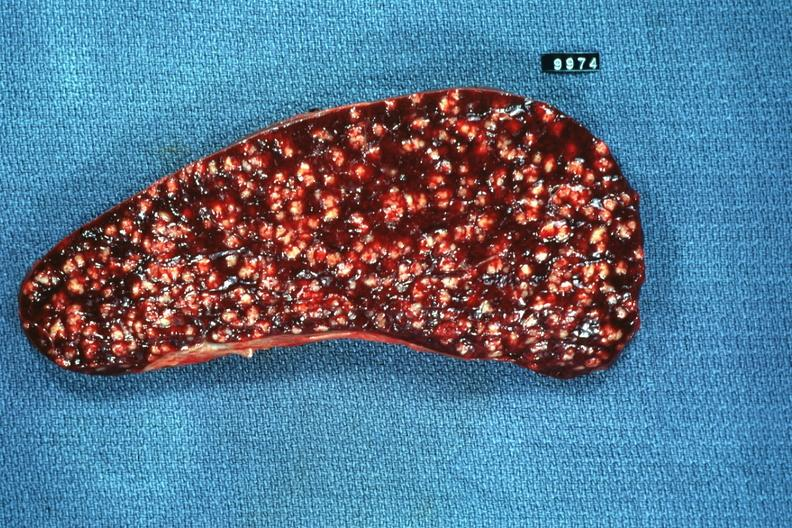what is present?
Answer the question using a single word or phrase. Spleen 